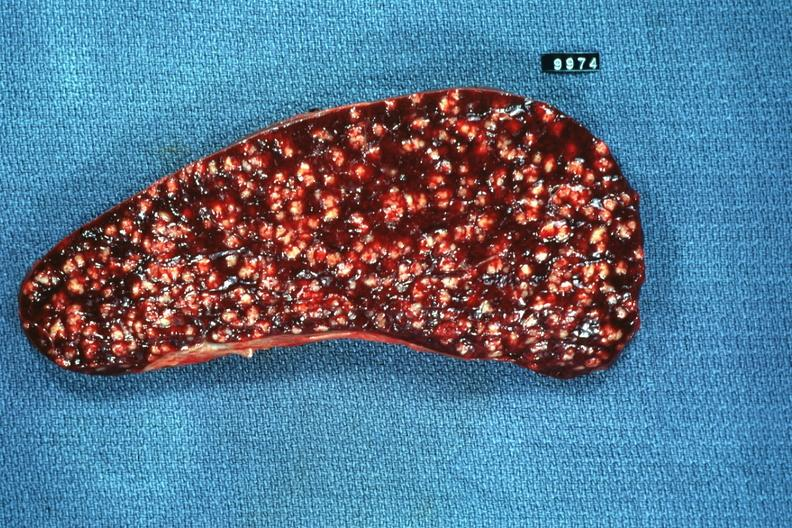what is present?
Answer the question using a single word or phrase. Spleen 